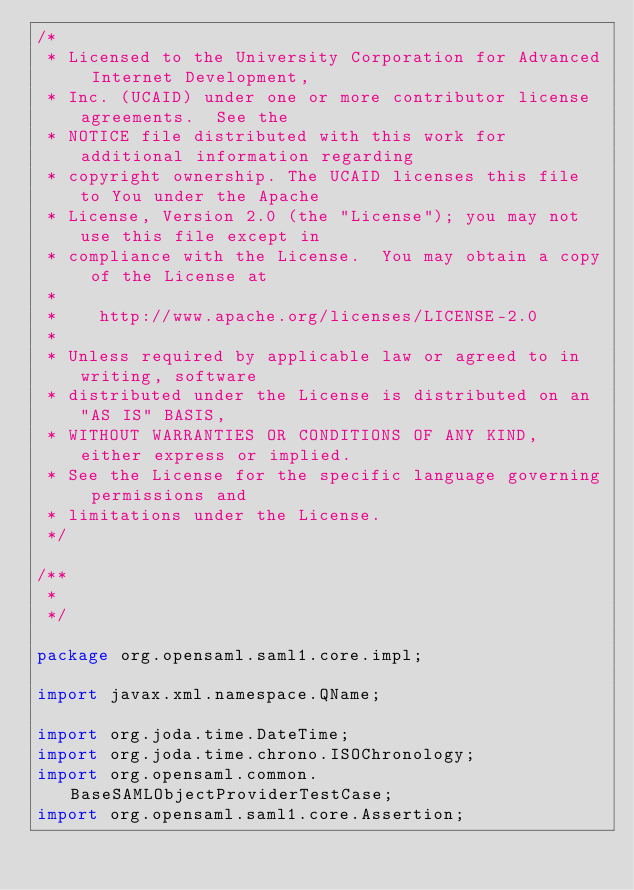<code> <loc_0><loc_0><loc_500><loc_500><_Java_>/*
 * Licensed to the University Corporation for Advanced Internet Development, 
 * Inc. (UCAID) under one or more contributor license agreements.  See the 
 * NOTICE file distributed with this work for additional information regarding
 * copyright ownership. The UCAID licenses this file to You under the Apache 
 * License, Version 2.0 (the "License"); you may not use this file except in 
 * compliance with the License.  You may obtain a copy of the License at
 *
 *    http://www.apache.org/licenses/LICENSE-2.0
 *
 * Unless required by applicable law or agreed to in writing, software
 * distributed under the License is distributed on an "AS IS" BASIS,
 * WITHOUT WARRANTIES OR CONDITIONS OF ANY KIND, either express or implied.
 * See the License for the specific language governing permissions and
 * limitations under the License.
 */

/**
 * 
 */

package org.opensaml.saml1.core.impl;

import javax.xml.namespace.QName;

import org.joda.time.DateTime;
import org.joda.time.chrono.ISOChronology;
import org.opensaml.common.BaseSAMLObjectProviderTestCase;
import org.opensaml.saml1.core.Assertion;</code> 